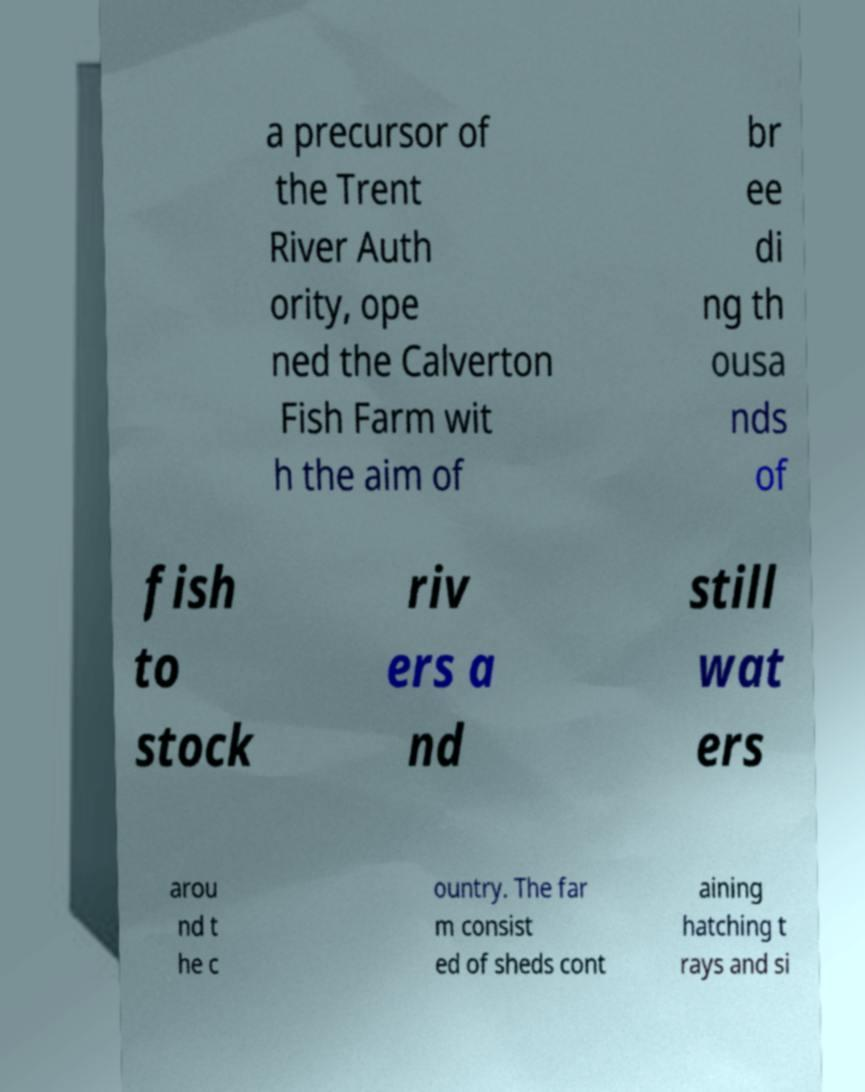There's text embedded in this image that I need extracted. Can you transcribe it verbatim? a precursor of the Trent River Auth ority, ope ned the Calverton Fish Farm wit h the aim of br ee di ng th ousa nds of fish to stock riv ers a nd still wat ers arou nd t he c ountry. The far m consist ed of sheds cont aining hatching t rays and si 